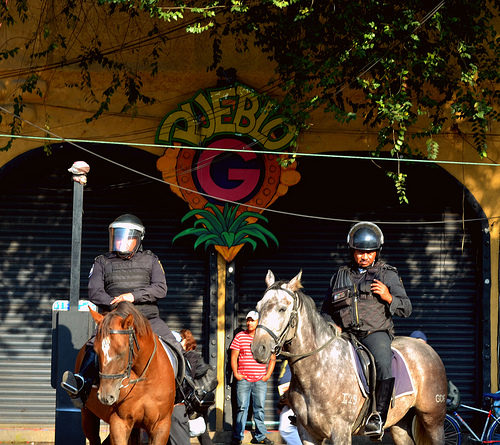What time of day does it appear to be in the image? Judging by the shadows and the warm lighting, it seems to be late afternoon. The long shadows suggest the sun is lower in the sky. 